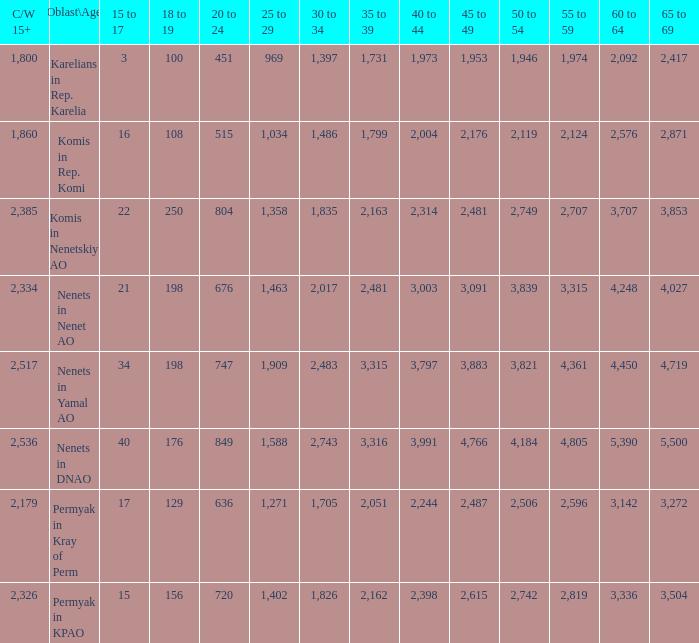With a 20 to 24 less than 676, and a 15 to 17 greater than 16, and a 60 to 64 less than 3,142, what is the average 45 to 49? None. 